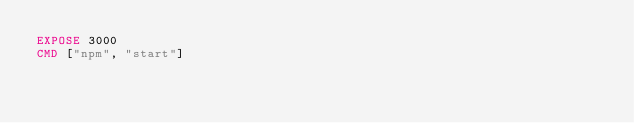Convert code to text. <code><loc_0><loc_0><loc_500><loc_500><_Dockerfile_>EXPOSE 3000
CMD ["npm", "start"]
</code> 